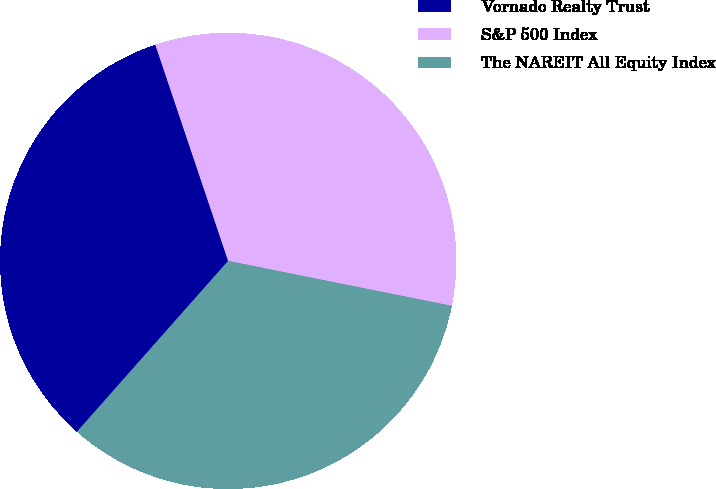Convert chart. <chart><loc_0><loc_0><loc_500><loc_500><pie_chart><fcel>Vornado Realty Trust<fcel>S&P 500 Index<fcel>The NAREIT All Equity Index<nl><fcel>33.3%<fcel>33.33%<fcel>33.37%<nl></chart> 